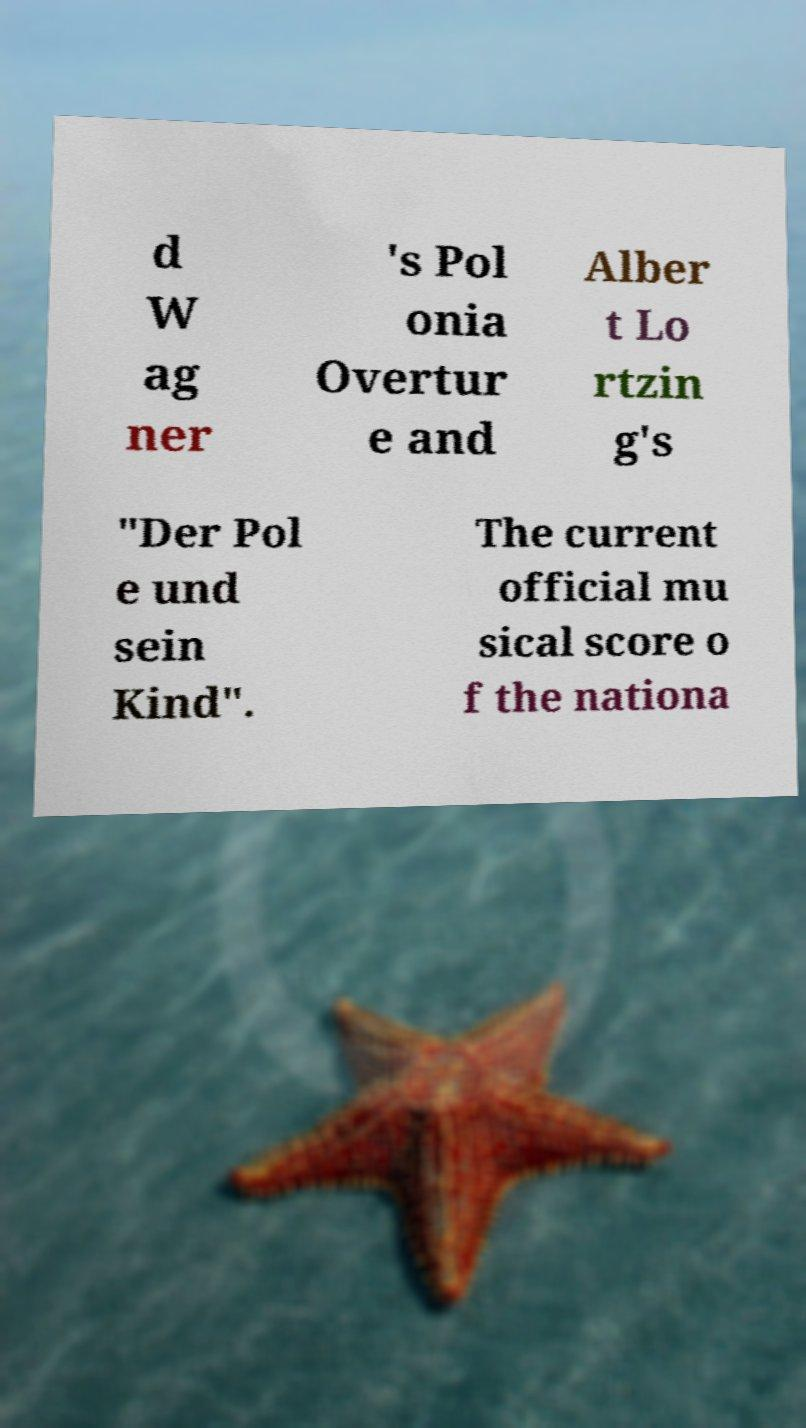What messages or text are displayed in this image? I need them in a readable, typed format. d W ag ner 's Pol onia Overtur e and Alber t Lo rtzin g's "Der Pol e und sein Kind". The current official mu sical score o f the nationa 